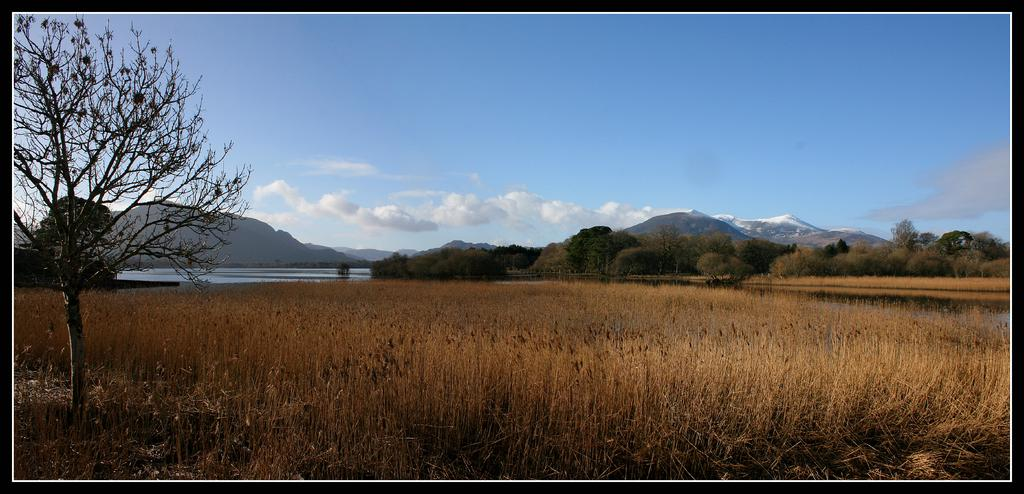What type of vegetation is present in the image? There is grass in the image. What other natural elements can be seen in the image? There are trees and water visible in the image. What type of landscape feature is present in the image? There are mountains in the image. What is visible in the background of the image? The sky is visible in the background of the image. What can be observed in the sky? There are clouds in the sky. What type of apparel are the women wearing in the image? There are no women present in the image, so it is not possible to determine what type of apparel they might be wearing. 